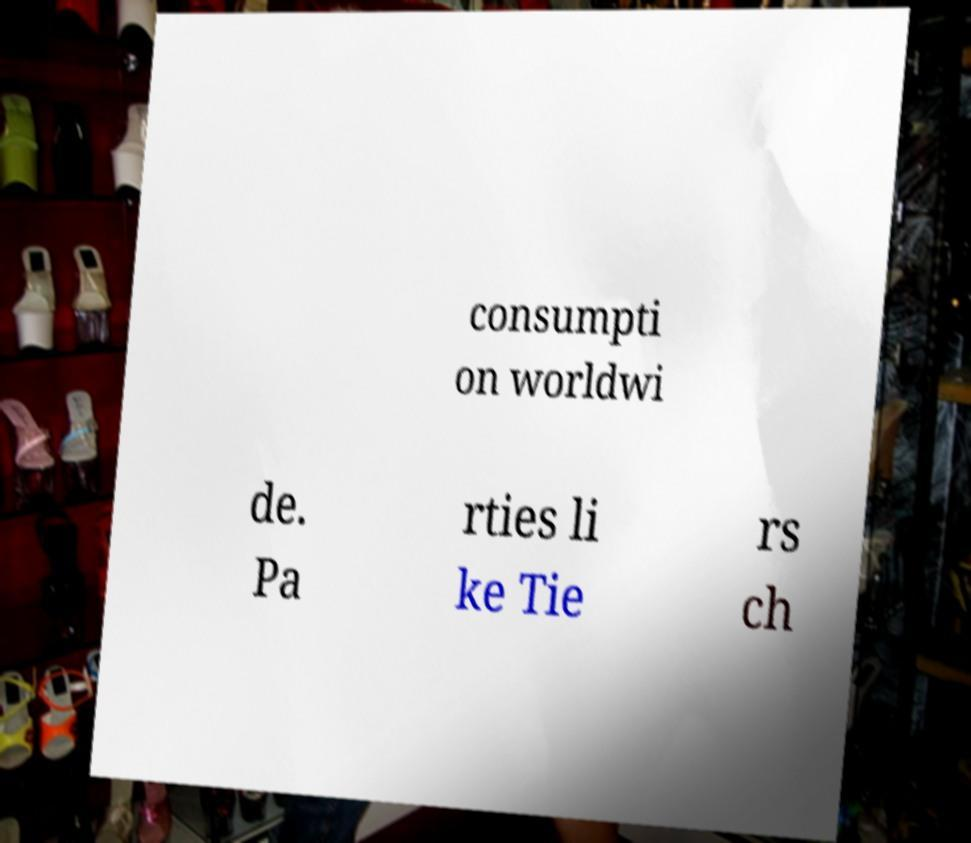Could you extract and type out the text from this image? consumpti on worldwi de. Pa rties li ke Tie rs ch 